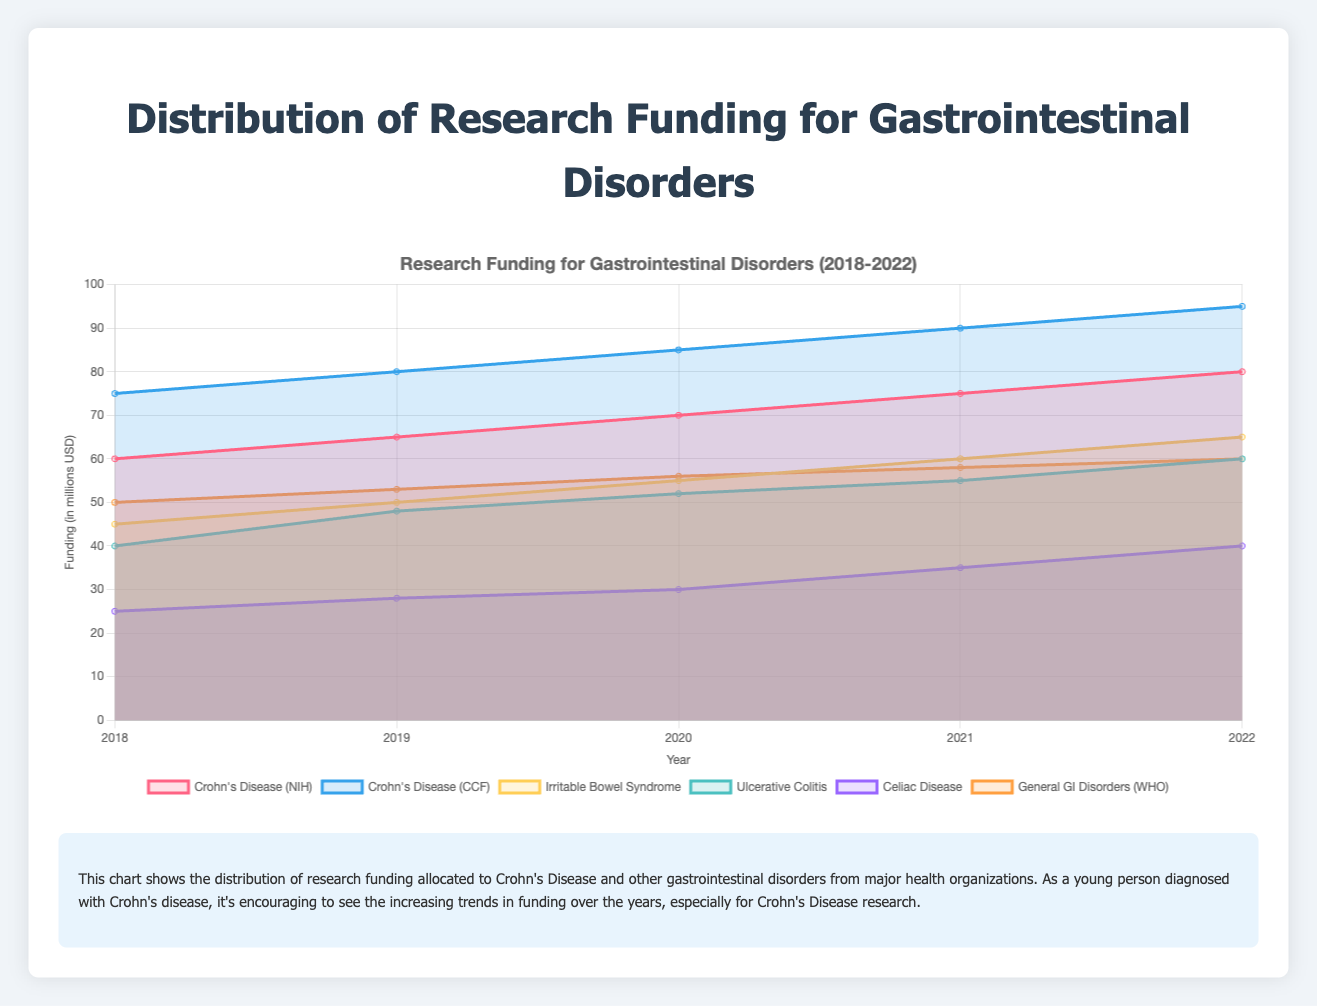What is the title of the chart? The title is typically found at the top of the chart, summarizing its content.
Answer: Distribution of Research Funding for Gastrointestinal Disorders What year has the highest research funding for Crohn's Disease from the National Institutes of Health? Look at the line representing Crohn's Disease (NIH) and identify the year where this line reaches its peak.
Answer: 2022 How does the funding for Irritable Bowel Syndrome change from 2018 to 2022? Observe the trend for the line representing Irritable Bowel Syndrome; note the starting value in 2018 and the ending value in 2022.
Answer: Increased from 45 to 65 million USD What is the average funding allocated to Crohn's Disease by the Crohn's and Colitis Foundation between 2018 and 2022? Add the funding amounts for each year and divide by the number of years: (75 + 80 + 85 + 90 + 95)/5.
Answer: 85 million USD Which gastrointestinal disorder had the lowest funding from the National Institutes of Health in 2021? Identify the lowest point among the 2021 data points for all disorders funded by the NIH.
Answer: Celiac Disease How does the trend in funding for General Gastrointestinal Disorders by the WHO compare to that of Crohn's Disease by the NIH? Compare the overall trends and slopes of the lines; note any increases or decreases.
Answer: Both show an upward trend, but Crohn's Disease (NIH) has a steeper increase Which organization allocated more funding to Crohn's Disease in 2020, the National Institutes of Health or the Crohn's and Colitis Foundation? Compare the 2020 data points for Crohn's Disease funding from both organizations.
Answer: Crohn's and Colitis Foundation What is the difference in funding for Ulcerative Colitis between 2018 and 2022? Subtract the funding amount for Ulcerative Colitis in 2018 from that in 2022: 60 - 40.
Answer: 20 million USD Which year showed the largest jump in funding for Celiac Disease by the National Institutes of Health? Find the year-over-year increase and determine where the increase is the largest.
Answer: 2021 (increase from 30 to 35 million USD) What is the total research funding allocated to gastrointestinal disorders by the World Health Organization over the observed years? Sum the funding values for General Gastrointestinal Disorders (WHO) across all years: 50 + 53 + 56 + 58 + 60.
Answer: 277 million USD 